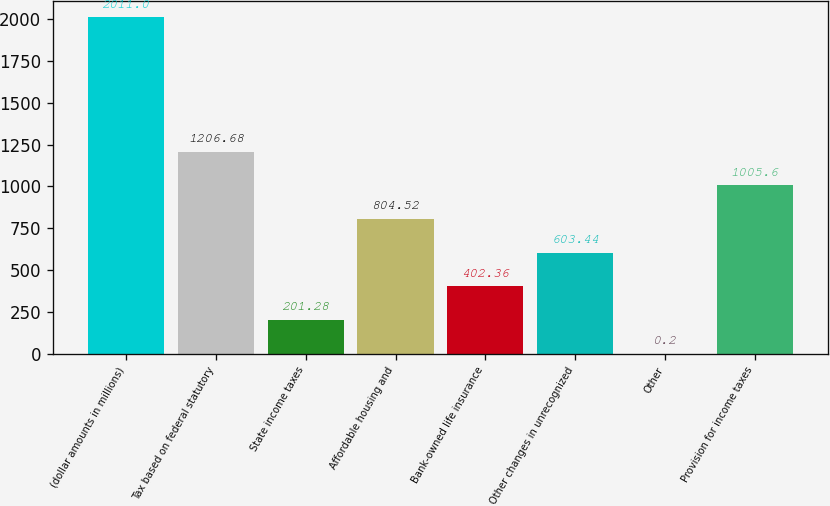<chart> <loc_0><loc_0><loc_500><loc_500><bar_chart><fcel>(dollar amounts in millions)<fcel>Tax based on federal statutory<fcel>State income taxes<fcel>Affordable housing and<fcel>Bank-owned life insurance<fcel>Other changes in unrecognized<fcel>Other<fcel>Provision for income taxes<nl><fcel>2011<fcel>1206.68<fcel>201.28<fcel>804.52<fcel>402.36<fcel>603.44<fcel>0.2<fcel>1005.6<nl></chart> 